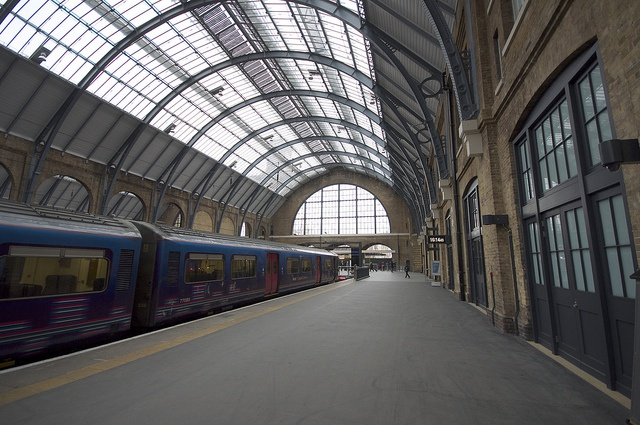Describe the objects in this image and their specific colors. I can see train in white, black, gray, and navy tones, people in white, black, and gray tones, people in white, black, and gray tones, people in black, gray, darkgray, and white tones, and people in white, black, and gray tones in this image. 